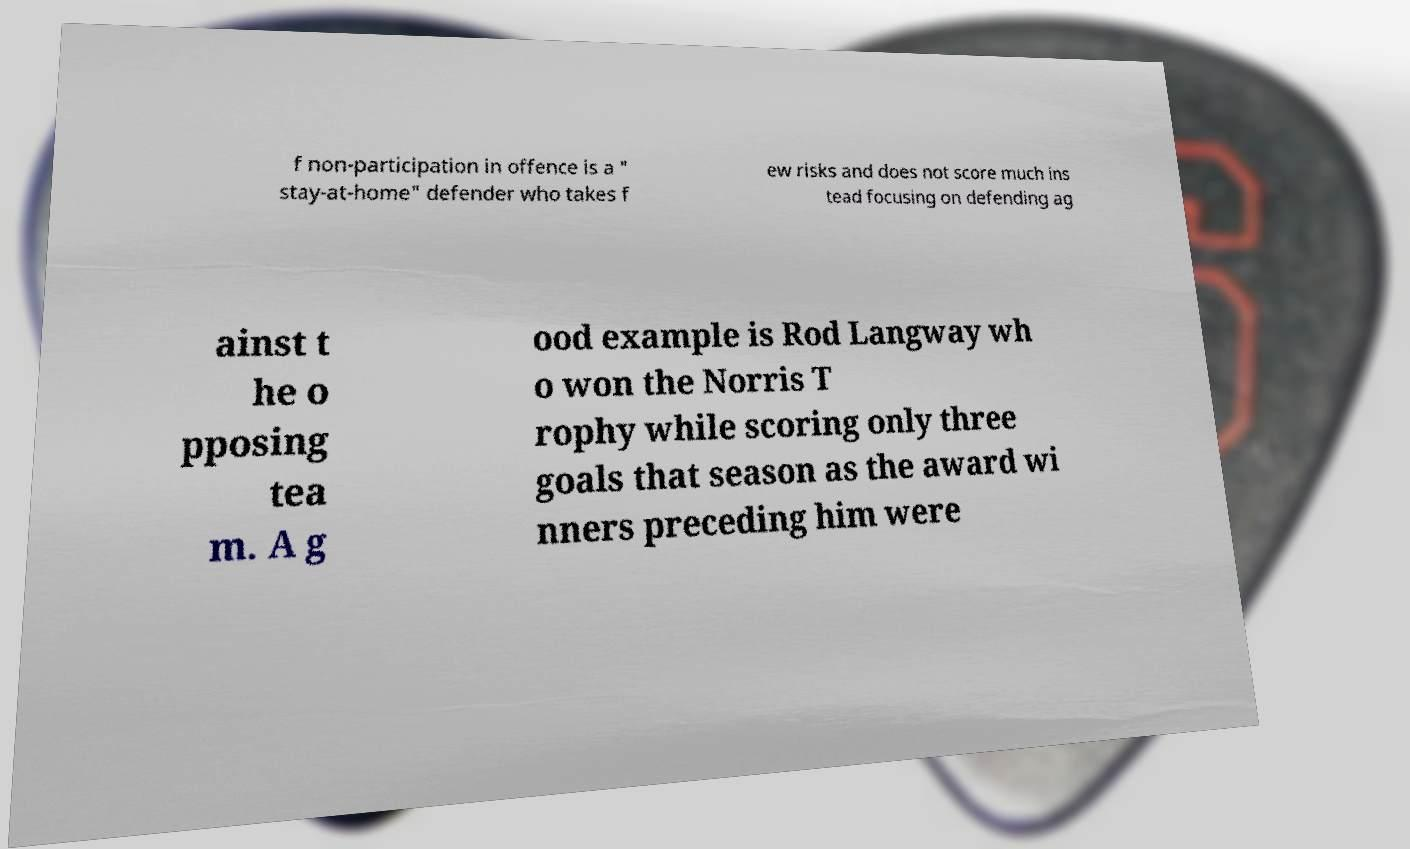For documentation purposes, I need the text within this image transcribed. Could you provide that? f non-participation in offence is a " stay-at-home" defender who takes f ew risks and does not score much ins tead focusing on defending ag ainst t he o pposing tea m. A g ood example is Rod Langway wh o won the Norris T rophy while scoring only three goals that season as the award wi nners preceding him were 